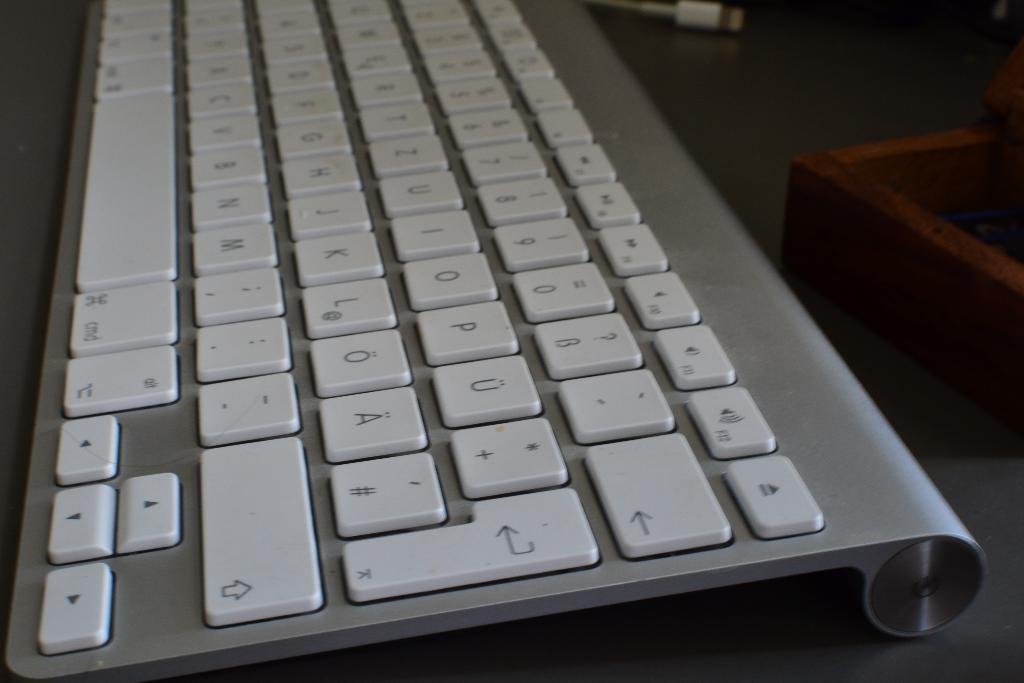<image>
Render a clear and concise summary of the photo. a close up of a key board with letter keys like P and O 